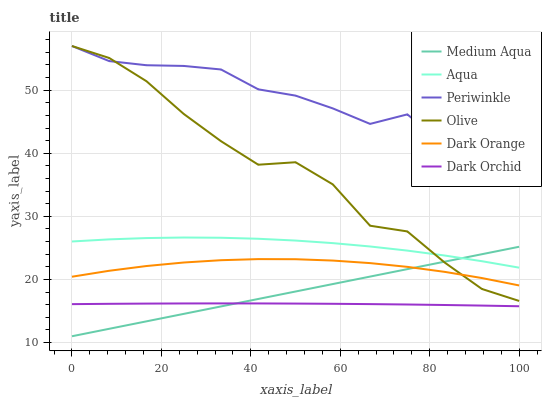Does Dark Orchid have the minimum area under the curve?
Answer yes or no. Yes. Does Periwinkle have the maximum area under the curve?
Answer yes or no. Yes. Does Aqua have the minimum area under the curve?
Answer yes or no. No. Does Aqua have the maximum area under the curve?
Answer yes or no. No. Is Medium Aqua the smoothest?
Answer yes or no. Yes. Is Olive the roughest?
Answer yes or no. Yes. Is Aqua the smoothest?
Answer yes or no. No. Is Aqua the roughest?
Answer yes or no. No. Does Medium Aqua have the lowest value?
Answer yes or no. Yes. Does Aqua have the lowest value?
Answer yes or no. No. Does Olive have the highest value?
Answer yes or no. Yes. Does Aqua have the highest value?
Answer yes or no. No. Is Dark Orchid less than Olive?
Answer yes or no. Yes. Is Periwinkle greater than Aqua?
Answer yes or no. Yes. Does Medium Aqua intersect Dark Orchid?
Answer yes or no. Yes. Is Medium Aqua less than Dark Orchid?
Answer yes or no. No. Is Medium Aqua greater than Dark Orchid?
Answer yes or no. No. Does Dark Orchid intersect Olive?
Answer yes or no. No. 